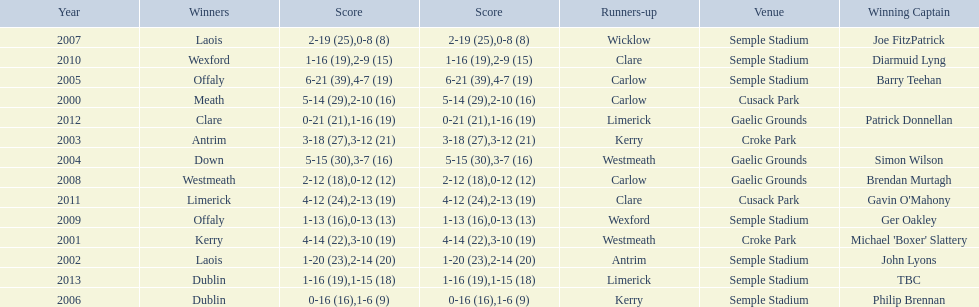Which team was the first to win with a team captain? Kerry. 